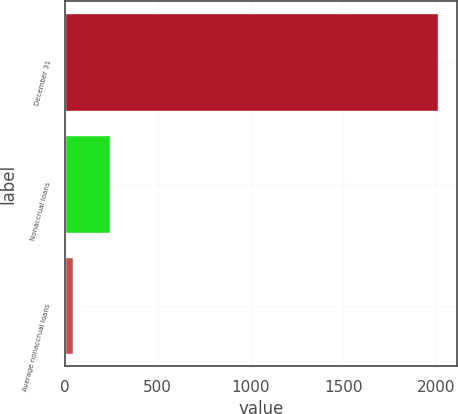Convert chart. <chart><loc_0><loc_0><loc_500><loc_500><bar_chart><fcel>December 31<fcel>Nonaccrual loans<fcel>Average nonaccrual loans<nl><fcel>2013<fcel>240<fcel>43<nl></chart> 